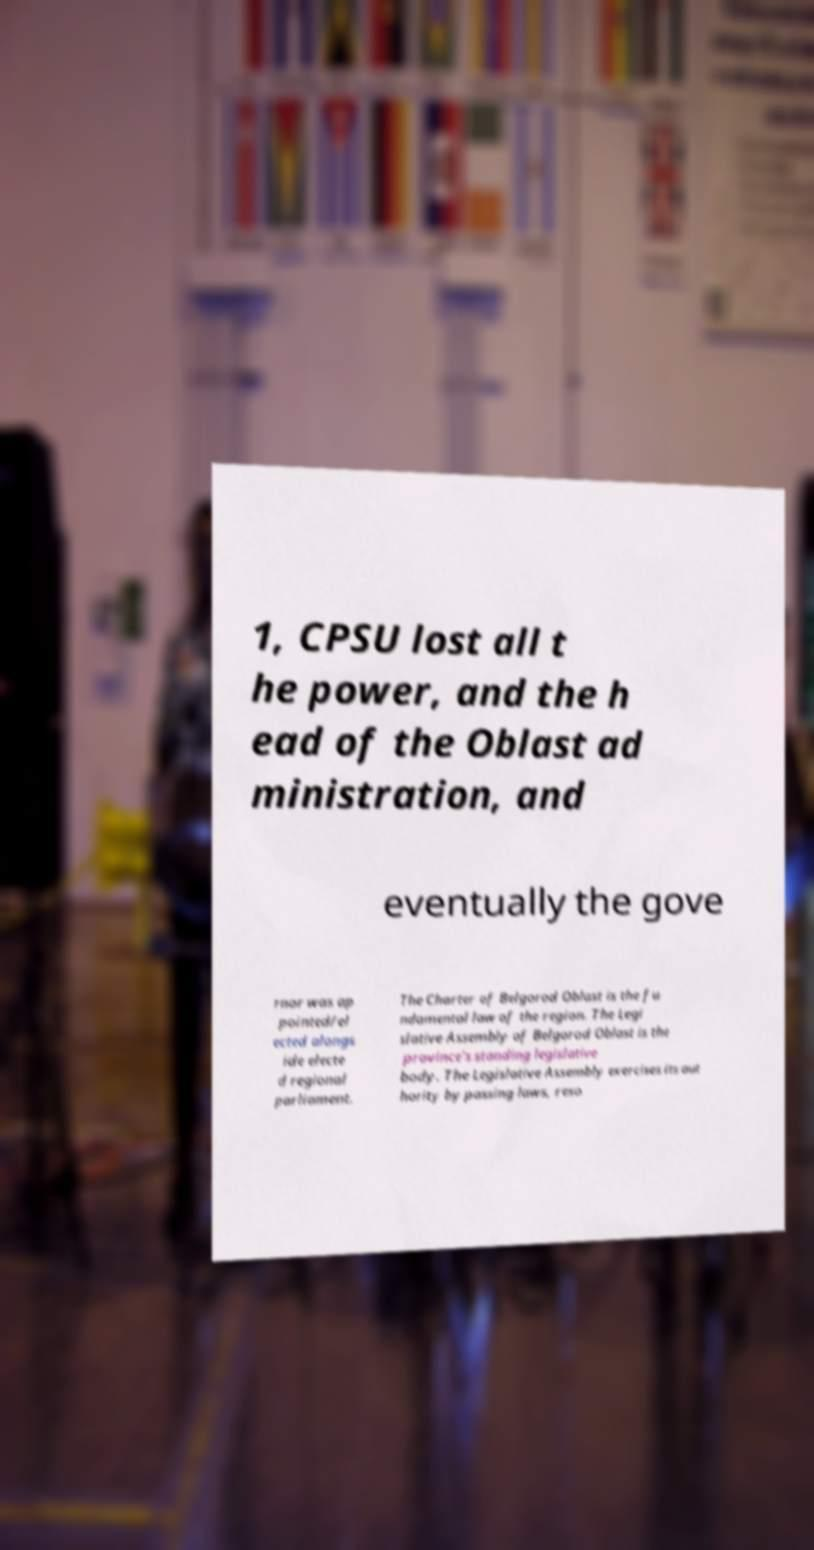Could you assist in decoding the text presented in this image and type it out clearly? 1, CPSU lost all t he power, and the h ead of the Oblast ad ministration, and eventually the gove rnor was ap pointed/el ected alongs ide electe d regional parliament. The Charter of Belgorod Oblast is the fu ndamental law of the region. The Legi slative Assembly of Belgorod Oblast is the province's standing legislative body. The Legislative Assembly exercises its aut hority by passing laws, reso 